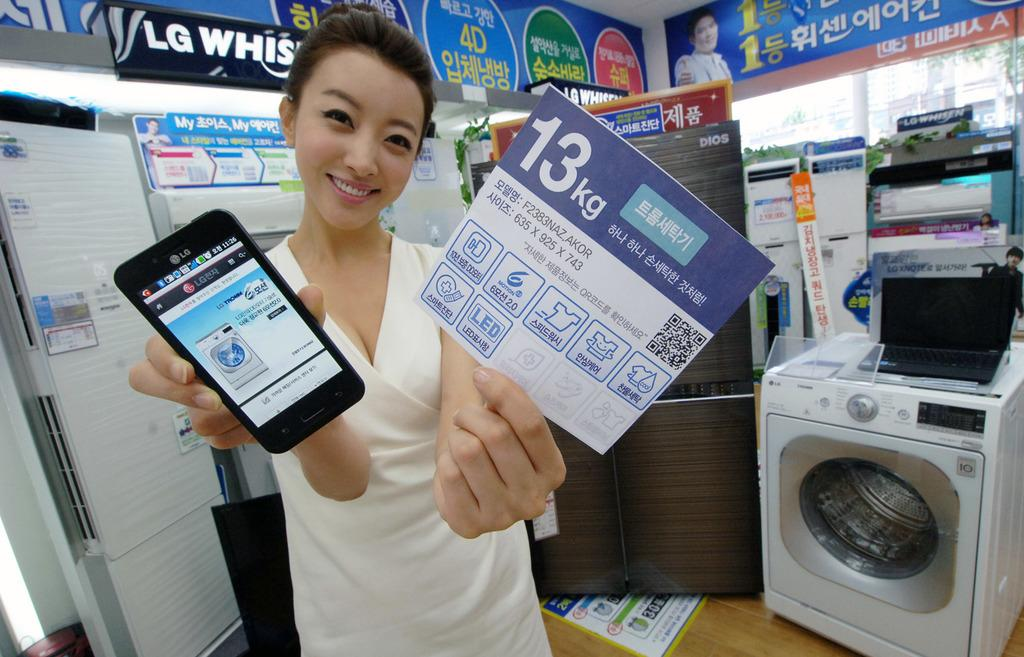Provide a one-sentence caption for the provided image. LG phone showing a LG washer machine on screen. 